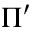Convert formula to latex. <formula><loc_0><loc_0><loc_500><loc_500>\Pi ^ { \prime }</formula> 